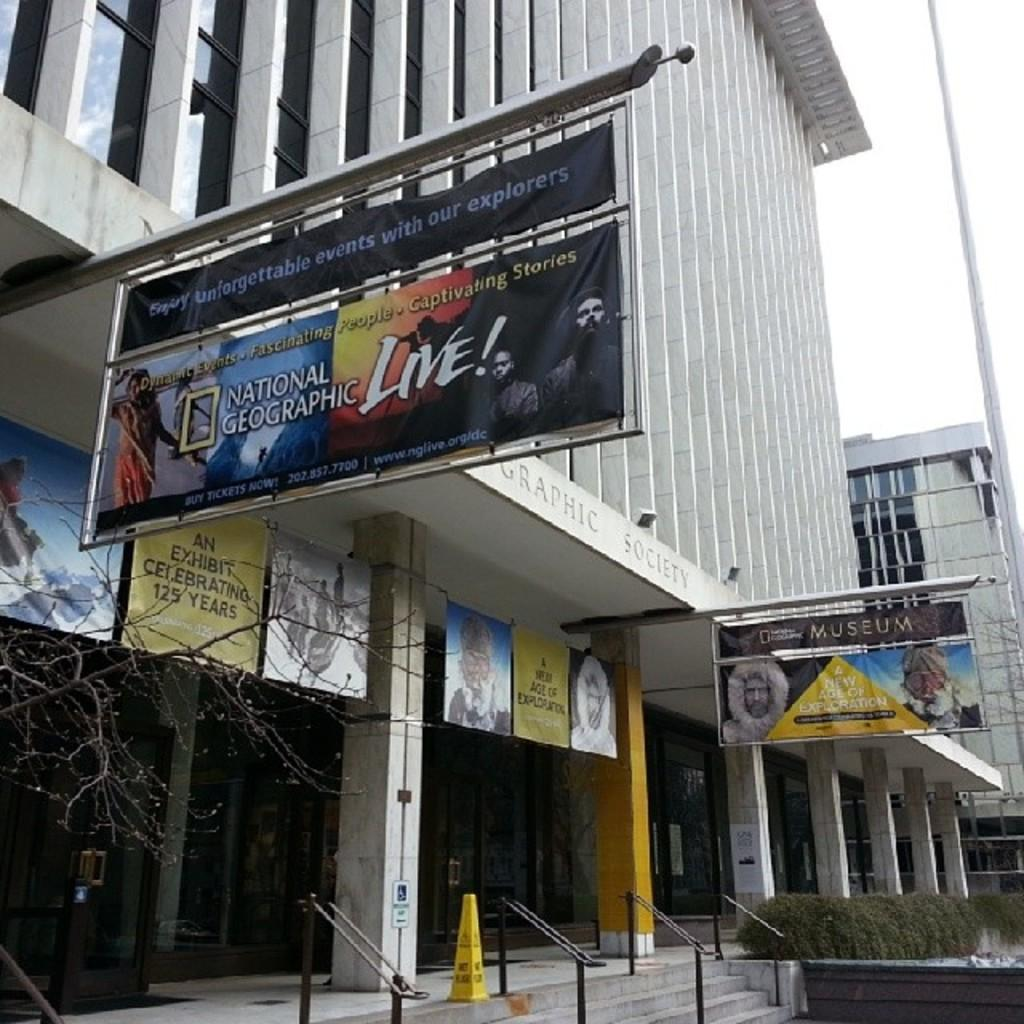Provide a one-sentence caption for the provided image. A building with an attached banner on a pole for National Geographic Live,. 